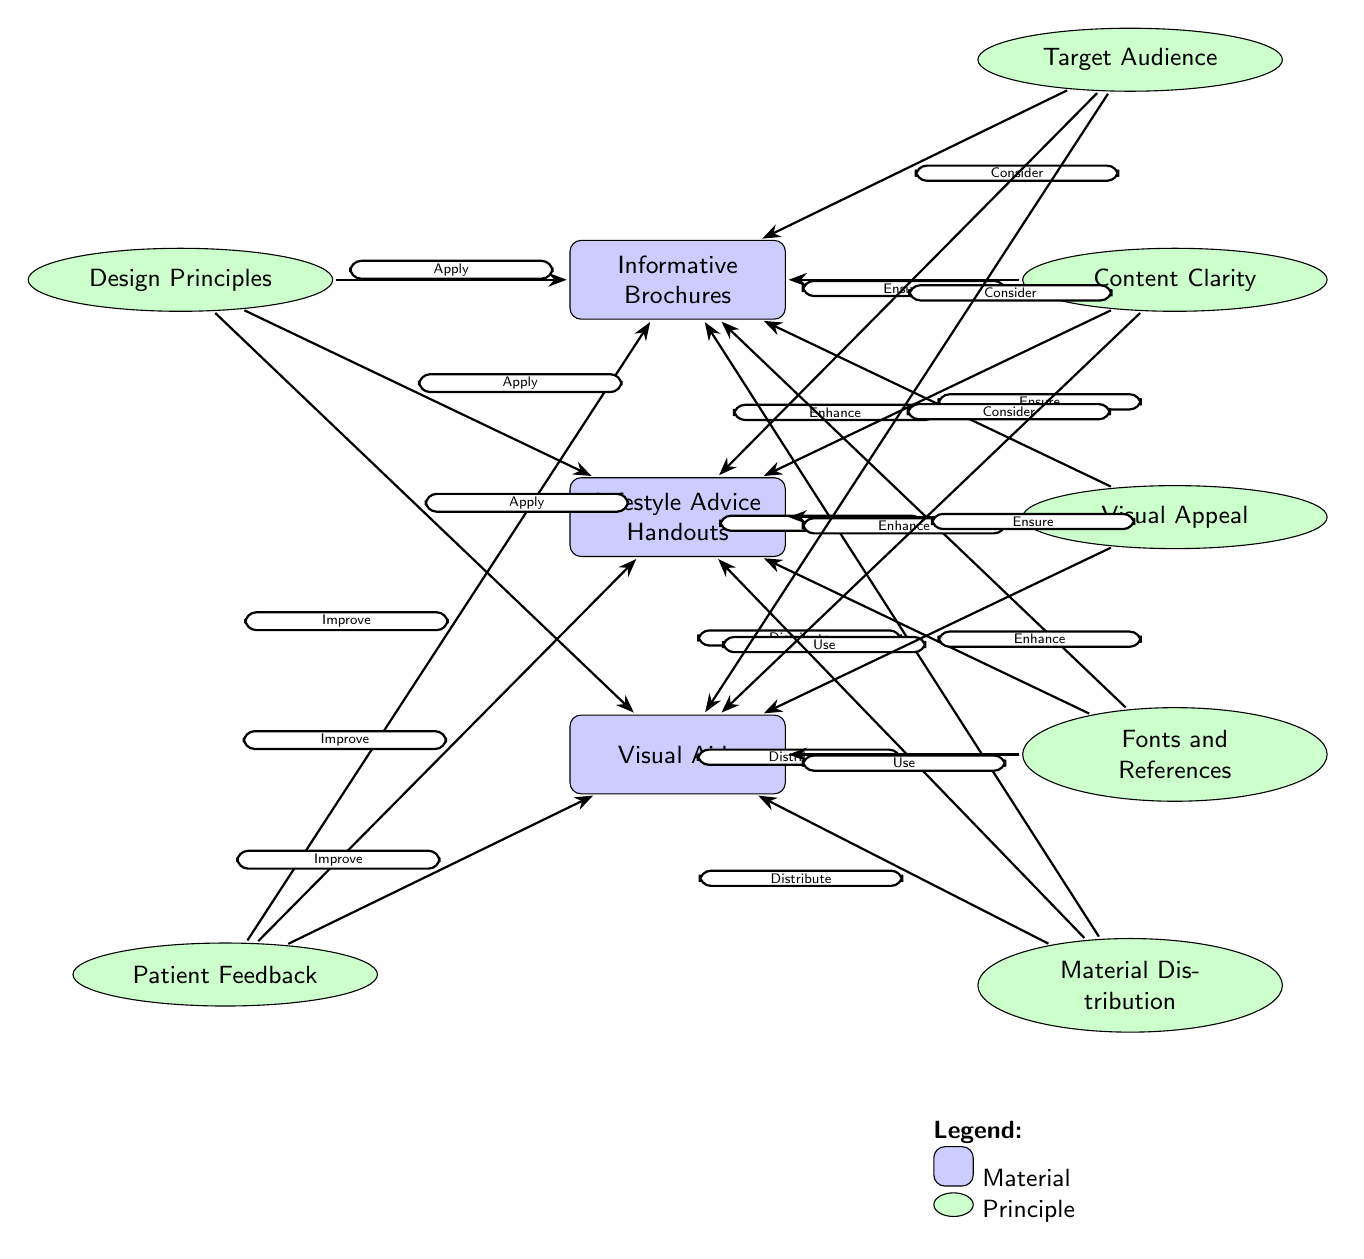What materials are depicted in the diagram? The diagram lists three materials: Informative Brochures, Lifestyle Advice Handouts, and Visual Aids. These are shown at the bottom of the diagram, specifically labeled as materials in blue rectangles.
Answer: Informative Brochures, Lifestyle Advice Handouts, Visual Aids What principle is located directly to the left of Informative Brochures? The principle directly to the left of Informative Brochures is Design Principles, as indicated by its position in the diagram. The layout shows it clearly aligned to the left of that node.
Answer: Design Principles How many principles are identified in the diagram? There are six principles identified throughout the diagram: Design Principles, Target Audience, Content Clarity, Visual Appeal, Fonts and References, Patient Feedback, and Material Distribution. Counting each ellipse shows a total of six principles.
Answer: Six Which principles contribute to enhancing the materials? The principles contributing to enhancing the materials are Design Principles, Target Audience, Content Clarity, Visual Appeal, and Fonts and References. Each of these principles points to the materials with a connection arrow indicating its role in effective material creation.
Answer: Design Principles, Target Audience, Content Clarity, Visual Appeal, Fonts and References What should be done to the materials according to the principle Feedback? The principle Feedback indicates that patient feedback should be used to improve the materials. This is suggested by the direction of the arrow leading from the Feedback principle to the material nodes, suggesting a positive relationship.
Answer: Improve What is the relationship between Visual Aids and Material Distribution? The relationship indicates that Material Distribution is linked to Visual Aids as indicated by the arrow which highlights that distribution is an action associated with visual aids. The flow shows that once created, visual aids should be distributed.
Answer: Distribute Which principle is specifically about the audience? The principle specifically about the audience is Target Audience, which is highlighted in an ellipse above the Informative Brochures node, showing its relevance to the content aimed at the patients.
Answer: Target Audience 